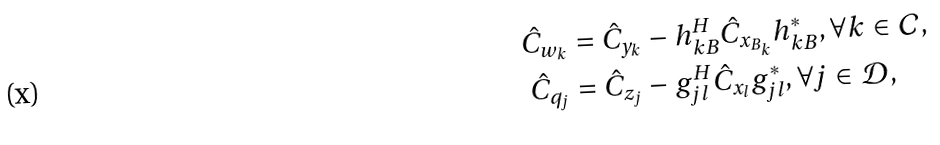Convert formula to latex. <formula><loc_0><loc_0><loc_500><loc_500>\hat { C } _ { w _ { k } } & = \hat { C } _ { y _ { k } } - { h } ^ { H } _ { k B } { \hat { C } } _ { x _ { B _ { k } } } { h } ^ { * } _ { k B } , \forall k \in \mathcal { C } , \\ \hat { C } _ { q _ { j } } & = \hat { C } _ { z _ { j } } - { g } ^ { H } _ { j l } { \hat { C } } _ { x _ { l } } { g } ^ { * } _ { j l } , \forall j \in \mathcal { D } ,</formula> 